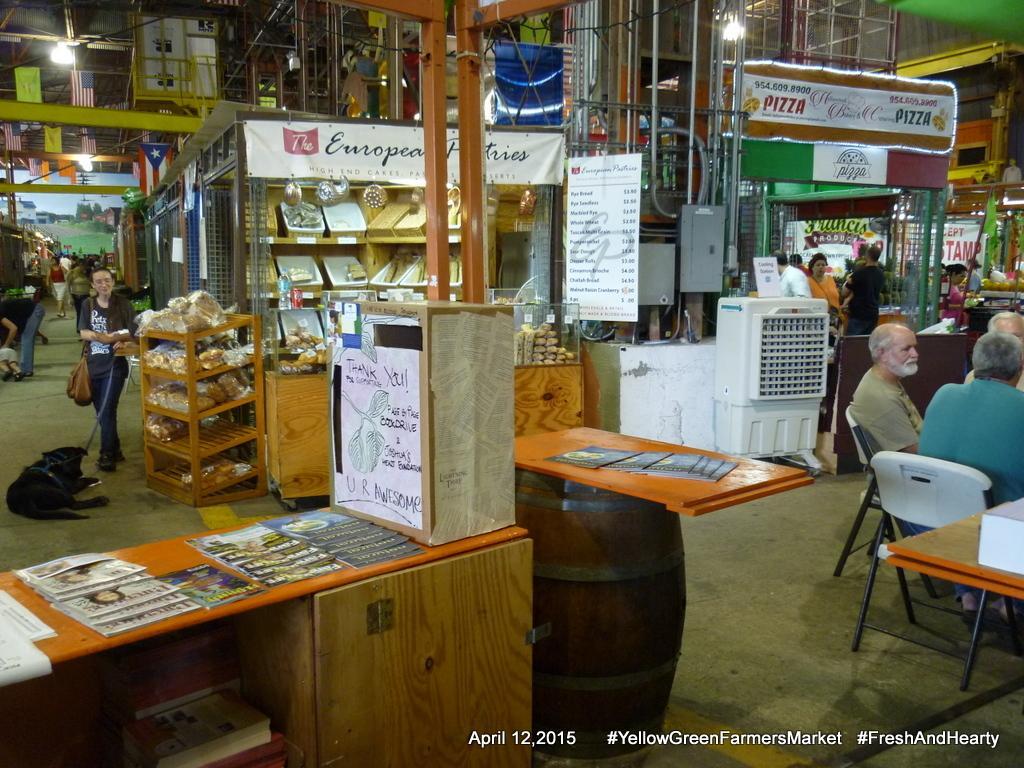Could you give a brief overview of what you see in this image? The picture is taken inside a mall. There are small stalls in it. In the below left corner of the image there is a table and papers are placed on it and there is a barrel just beside it. On the below right corner of the image there are few people sitting on the chairs and other few are at the stalls. There is a stall of European Pastries and Pizza. There are boards displayed at the stalls. In the right there is woman wearing a bag and holding a dog with help of leash. Beside her is a rack and there is food in it and behind her there is crowd. There are flags and lights hung. In the below right corner there is some text written. 